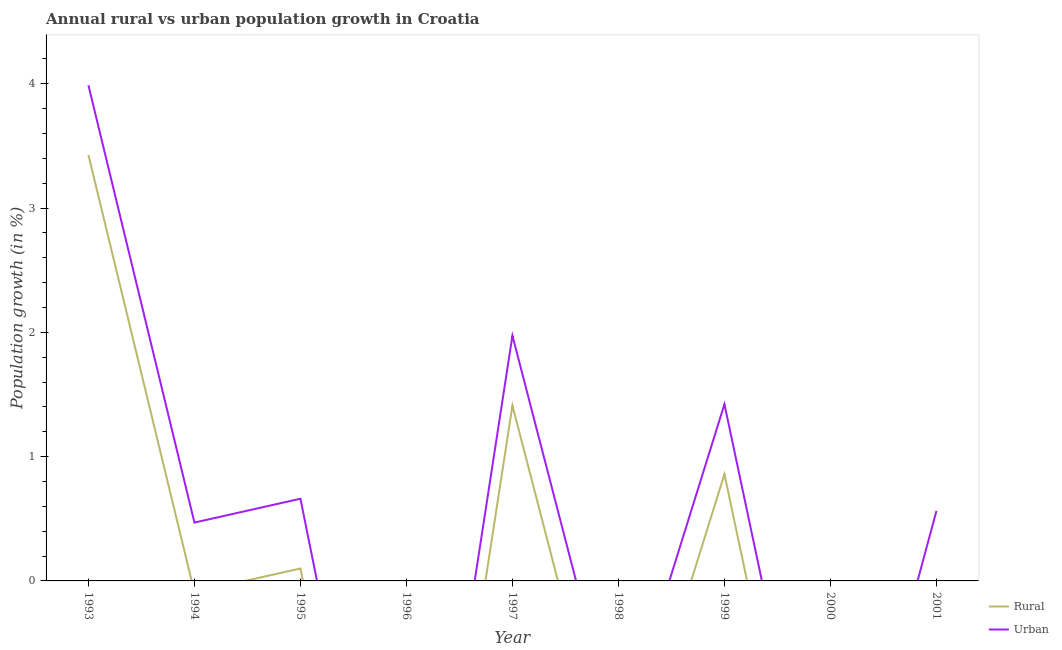How many different coloured lines are there?
Offer a terse response. 2. Is the number of lines equal to the number of legend labels?
Offer a very short reply. No. What is the urban population growth in 2001?
Give a very brief answer. 0.56. Across all years, what is the maximum rural population growth?
Provide a short and direct response. 3.43. In which year was the urban population growth maximum?
Provide a short and direct response. 1993. What is the total rural population growth in the graph?
Offer a very short reply. 5.8. What is the difference between the urban population growth in 1995 and that in 1997?
Your response must be concise. -1.31. What is the difference between the rural population growth in 1996 and the urban population growth in 1994?
Keep it short and to the point. -0.47. What is the average rural population growth per year?
Provide a short and direct response. 0.64. In the year 1997, what is the difference between the urban population growth and rural population growth?
Offer a terse response. 0.56. In how many years, is the urban population growth greater than 0.8 %?
Make the answer very short. 3. Is the urban population growth in 1994 less than that in 1999?
Make the answer very short. Yes. Is the difference between the urban population growth in 1993 and 1997 greater than the difference between the rural population growth in 1993 and 1997?
Provide a short and direct response. No. What is the difference between the highest and the second highest rural population growth?
Keep it short and to the point. 2.02. What is the difference between the highest and the lowest urban population growth?
Give a very brief answer. 3.99. Is the sum of the rural population growth in 1997 and 2001 greater than the maximum urban population growth across all years?
Offer a terse response. No. Is the urban population growth strictly greater than the rural population growth over the years?
Give a very brief answer. Yes. Is the urban population growth strictly less than the rural population growth over the years?
Your answer should be compact. No. How many years are there in the graph?
Ensure brevity in your answer.  9. Does the graph contain grids?
Give a very brief answer. No. How are the legend labels stacked?
Give a very brief answer. Vertical. What is the title of the graph?
Offer a very short reply. Annual rural vs urban population growth in Croatia. Does "Exports of goods" appear as one of the legend labels in the graph?
Keep it short and to the point. No. What is the label or title of the Y-axis?
Make the answer very short. Population growth (in %). What is the Population growth (in %) in Rural in 1993?
Provide a short and direct response. 3.43. What is the Population growth (in %) of Urban  in 1993?
Make the answer very short. 3.99. What is the Population growth (in %) in Urban  in 1994?
Your answer should be very brief. 0.47. What is the Population growth (in %) of Rural in 1995?
Your response must be concise. 0.1. What is the Population growth (in %) of Urban  in 1995?
Make the answer very short. 0.66. What is the Population growth (in %) of Rural in 1996?
Make the answer very short. 0. What is the Population growth (in %) of Rural in 1997?
Offer a terse response. 1.41. What is the Population growth (in %) of Urban  in 1997?
Offer a terse response. 1.97. What is the Population growth (in %) of Urban  in 1998?
Offer a terse response. 0. What is the Population growth (in %) in Rural in 1999?
Your answer should be compact. 0.86. What is the Population growth (in %) of Urban  in 1999?
Provide a short and direct response. 1.42. What is the Population growth (in %) in Rural in 2000?
Your answer should be compact. 0. What is the Population growth (in %) of Urban  in 2000?
Ensure brevity in your answer.  0. What is the Population growth (in %) in Rural in 2001?
Give a very brief answer. 0. What is the Population growth (in %) in Urban  in 2001?
Your response must be concise. 0.56. Across all years, what is the maximum Population growth (in %) in Rural?
Give a very brief answer. 3.43. Across all years, what is the maximum Population growth (in %) of Urban ?
Provide a short and direct response. 3.99. Across all years, what is the minimum Population growth (in %) in Rural?
Ensure brevity in your answer.  0. What is the total Population growth (in %) in Rural in the graph?
Your answer should be compact. 5.8. What is the total Population growth (in %) in Urban  in the graph?
Keep it short and to the point. 9.08. What is the difference between the Population growth (in %) in Urban  in 1993 and that in 1994?
Provide a short and direct response. 3.52. What is the difference between the Population growth (in %) in Rural in 1993 and that in 1995?
Ensure brevity in your answer.  3.33. What is the difference between the Population growth (in %) of Urban  in 1993 and that in 1995?
Keep it short and to the point. 3.33. What is the difference between the Population growth (in %) of Rural in 1993 and that in 1997?
Provide a succinct answer. 2.02. What is the difference between the Population growth (in %) in Urban  in 1993 and that in 1997?
Offer a very short reply. 2.01. What is the difference between the Population growth (in %) of Rural in 1993 and that in 1999?
Keep it short and to the point. 2.57. What is the difference between the Population growth (in %) of Urban  in 1993 and that in 1999?
Your answer should be compact. 2.57. What is the difference between the Population growth (in %) in Rural in 1993 and that in 2001?
Your answer should be very brief. 3.42. What is the difference between the Population growth (in %) of Urban  in 1993 and that in 2001?
Give a very brief answer. 3.42. What is the difference between the Population growth (in %) in Urban  in 1994 and that in 1995?
Make the answer very short. -0.19. What is the difference between the Population growth (in %) of Urban  in 1994 and that in 1997?
Your answer should be compact. -1.5. What is the difference between the Population growth (in %) of Urban  in 1994 and that in 1999?
Provide a short and direct response. -0.95. What is the difference between the Population growth (in %) of Urban  in 1994 and that in 2001?
Your answer should be very brief. -0.09. What is the difference between the Population growth (in %) of Rural in 1995 and that in 1997?
Give a very brief answer. -1.31. What is the difference between the Population growth (in %) of Urban  in 1995 and that in 1997?
Provide a succinct answer. -1.31. What is the difference between the Population growth (in %) of Rural in 1995 and that in 1999?
Keep it short and to the point. -0.76. What is the difference between the Population growth (in %) in Urban  in 1995 and that in 1999?
Make the answer very short. -0.76. What is the difference between the Population growth (in %) in Rural in 1995 and that in 2001?
Give a very brief answer. 0.1. What is the difference between the Population growth (in %) of Urban  in 1995 and that in 2001?
Give a very brief answer. 0.1. What is the difference between the Population growth (in %) in Rural in 1997 and that in 1999?
Provide a succinct answer. 0.55. What is the difference between the Population growth (in %) of Urban  in 1997 and that in 1999?
Give a very brief answer. 0.55. What is the difference between the Population growth (in %) in Rural in 1997 and that in 2001?
Give a very brief answer. 1.41. What is the difference between the Population growth (in %) of Urban  in 1997 and that in 2001?
Make the answer very short. 1.41. What is the difference between the Population growth (in %) of Rural in 1999 and that in 2001?
Provide a succinct answer. 0.85. What is the difference between the Population growth (in %) in Urban  in 1999 and that in 2001?
Offer a very short reply. 0.86. What is the difference between the Population growth (in %) of Rural in 1993 and the Population growth (in %) of Urban  in 1994?
Make the answer very short. 2.96. What is the difference between the Population growth (in %) in Rural in 1993 and the Population growth (in %) in Urban  in 1995?
Offer a terse response. 2.77. What is the difference between the Population growth (in %) in Rural in 1993 and the Population growth (in %) in Urban  in 1997?
Ensure brevity in your answer.  1.45. What is the difference between the Population growth (in %) of Rural in 1993 and the Population growth (in %) of Urban  in 1999?
Provide a short and direct response. 2.01. What is the difference between the Population growth (in %) in Rural in 1993 and the Population growth (in %) in Urban  in 2001?
Your answer should be compact. 2.86. What is the difference between the Population growth (in %) in Rural in 1995 and the Population growth (in %) in Urban  in 1997?
Your answer should be very brief. -1.87. What is the difference between the Population growth (in %) in Rural in 1995 and the Population growth (in %) in Urban  in 1999?
Offer a very short reply. -1.32. What is the difference between the Population growth (in %) of Rural in 1995 and the Population growth (in %) of Urban  in 2001?
Provide a succinct answer. -0.46. What is the difference between the Population growth (in %) in Rural in 1997 and the Population growth (in %) in Urban  in 1999?
Your answer should be compact. -0.01. What is the difference between the Population growth (in %) of Rural in 1997 and the Population growth (in %) of Urban  in 2001?
Provide a succinct answer. 0.85. What is the difference between the Population growth (in %) in Rural in 1999 and the Population growth (in %) in Urban  in 2001?
Make the answer very short. 0.3. What is the average Population growth (in %) in Rural per year?
Your response must be concise. 0.64. What is the average Population growth (in %) in Urban  per year?
Ensure brevity in your answer.  1.01. In the year 1993, what is the difference between the Population growth (in %) in Rural and Population growth (in %) in Urban ?
Your response must be concise. -0.56. In the year 1995, what is the difference between the Population growth (in %) in Rural and Population growth (in %) in Urban ?
Provide a short and direct response. -0.56. In the year 1997, what is the difference between the Population growth (in %) in Rural and Population growth (in %) in Urban ?
Make the answer very short. -0.56. In the year 1999, what is the difference between the Population growth (in %) in Rural and Population growth (in %) in Urban ?
Ensure brevity in your answer.  -0.56. In the year 2001, what is the difference between the Population growth (in %) in Rural and Population growth (in %) in Urban ?
Your answer should be very brief. -0.56. What is the ratio of the Population growth (in %) of Urban  in 1993 to that in 1994?
Make the answer very short. 8.49. What is the ratio of the Population growth (in %) of Rural in 1993 to that in 1995?
Your response must be concise. 34.22. What is the ratio of the Population growth (in %) in Urban  in 1993 to that in 1995?
Your answer should be compact. 6.03. What is the ratio of the Population growth (in %) of Rural in 1993 to that in 1997?
Ensure brevity in your answer.  2.43. What is the ratio of the Population growth (in %) of Urban  in 1993 to that in 1997?
Offer a very short reply. 2.02. What is the ratio of the Population growth (in %) of Rural in 1993 to that in 1999?
Provide a short and direct response. 3.99. What is the ratio of the Population growth (in %) in Urban  in 1993 to that in 1999?
Offer a very short reply. 2.8. What is the ratio of the Population growth (in %) of Rural in 1993 to that in 2001?
Provide a short and direct response. 740.25. What is the ratio of the Population growth (in %) of Urban  in 1993 to that in 2001?
Offer a terse response. 7.07. What is the ratio of the Population growth (in %) in Urban  in 1994 to that in 1995?
Your answer should be compact. 0.71. What is the ratio of the Population growth (in %) in Urban  in 1994 to that in 1997?
Give a very brief answer. 0.24. What is the ratio of the Population growth (in %) in Urban  in 1994 to that in 1999?
Provide a short and direct response. 0.33. What is the ratio of the Population growth (in %) in Urban  in 1994 to that in 2001?
Your response must be concise. 0.83. What is the ratio of the Population growth (in %) of Rural in 1995 to that in 1997?
Offer a terse response. 0.07. What is the ratio of the Population growth (in %) in Urban  in 1995 to that in 1997?
Keep it short and to the point. 0.34. What is the ratio of the Population growth (in %) of Rural in 1995 to that in 1999?
Give a very brief answer. 0.12. What is the ratio of the Population growth (in %) of Urban  in 1995 to that in 1999?
Provide a short and direct response. 0.47. What is the ratio of the Population growth (in %) in Rural in 1995 to that in 2001?
Keep it short and to the point. 21.63. What is the ratio of the Population growth (in %) of Urban  in 1995 to that in 2001?
Your answer should be compact. 1.17. What is the ratio of the Population growth (in %) in Rural in 1997 to that in 1999?
Provide a succinct answer. 1.64. What is the ratio of the Population growth (in %) in Urban  in 1997 to that in 1999?
Ensure brevity in your answer.  1.39. What is the ratio of the Population growth (in %) of Rural in 1997 to that in 2001?
Your answer should be very brief. 304.84. What is the ratio of the Population growth (in %) of Urban  in 1997 to that in 2001?
Ensure brevity in your answer.  3.5. What is the ratio of the Population growth (in %) in Rural in 1999 to that in 2001?
Give a very brief answer. 185.59. What is the ratio of the Population growth (in %) in Urban  in 1999 to that in 2001?
Keep it short and to the point. 2.52. What is the difference between the highest and the second highest Population growth (in %) of Rural?
Provide a succinct answer. 2.02. What is the difference between the highest and the second highest Population growth (in %) of Urban ?
Give a very brief answer. 2.01. What is the difference between the highest and the lowest Population growth (in %) in Rural?
Give a very brief answer. 3.43. What is the difference between the highest and the lowest Population growth (in %) in Urban ?
Offer a very short reply. 3.99. 